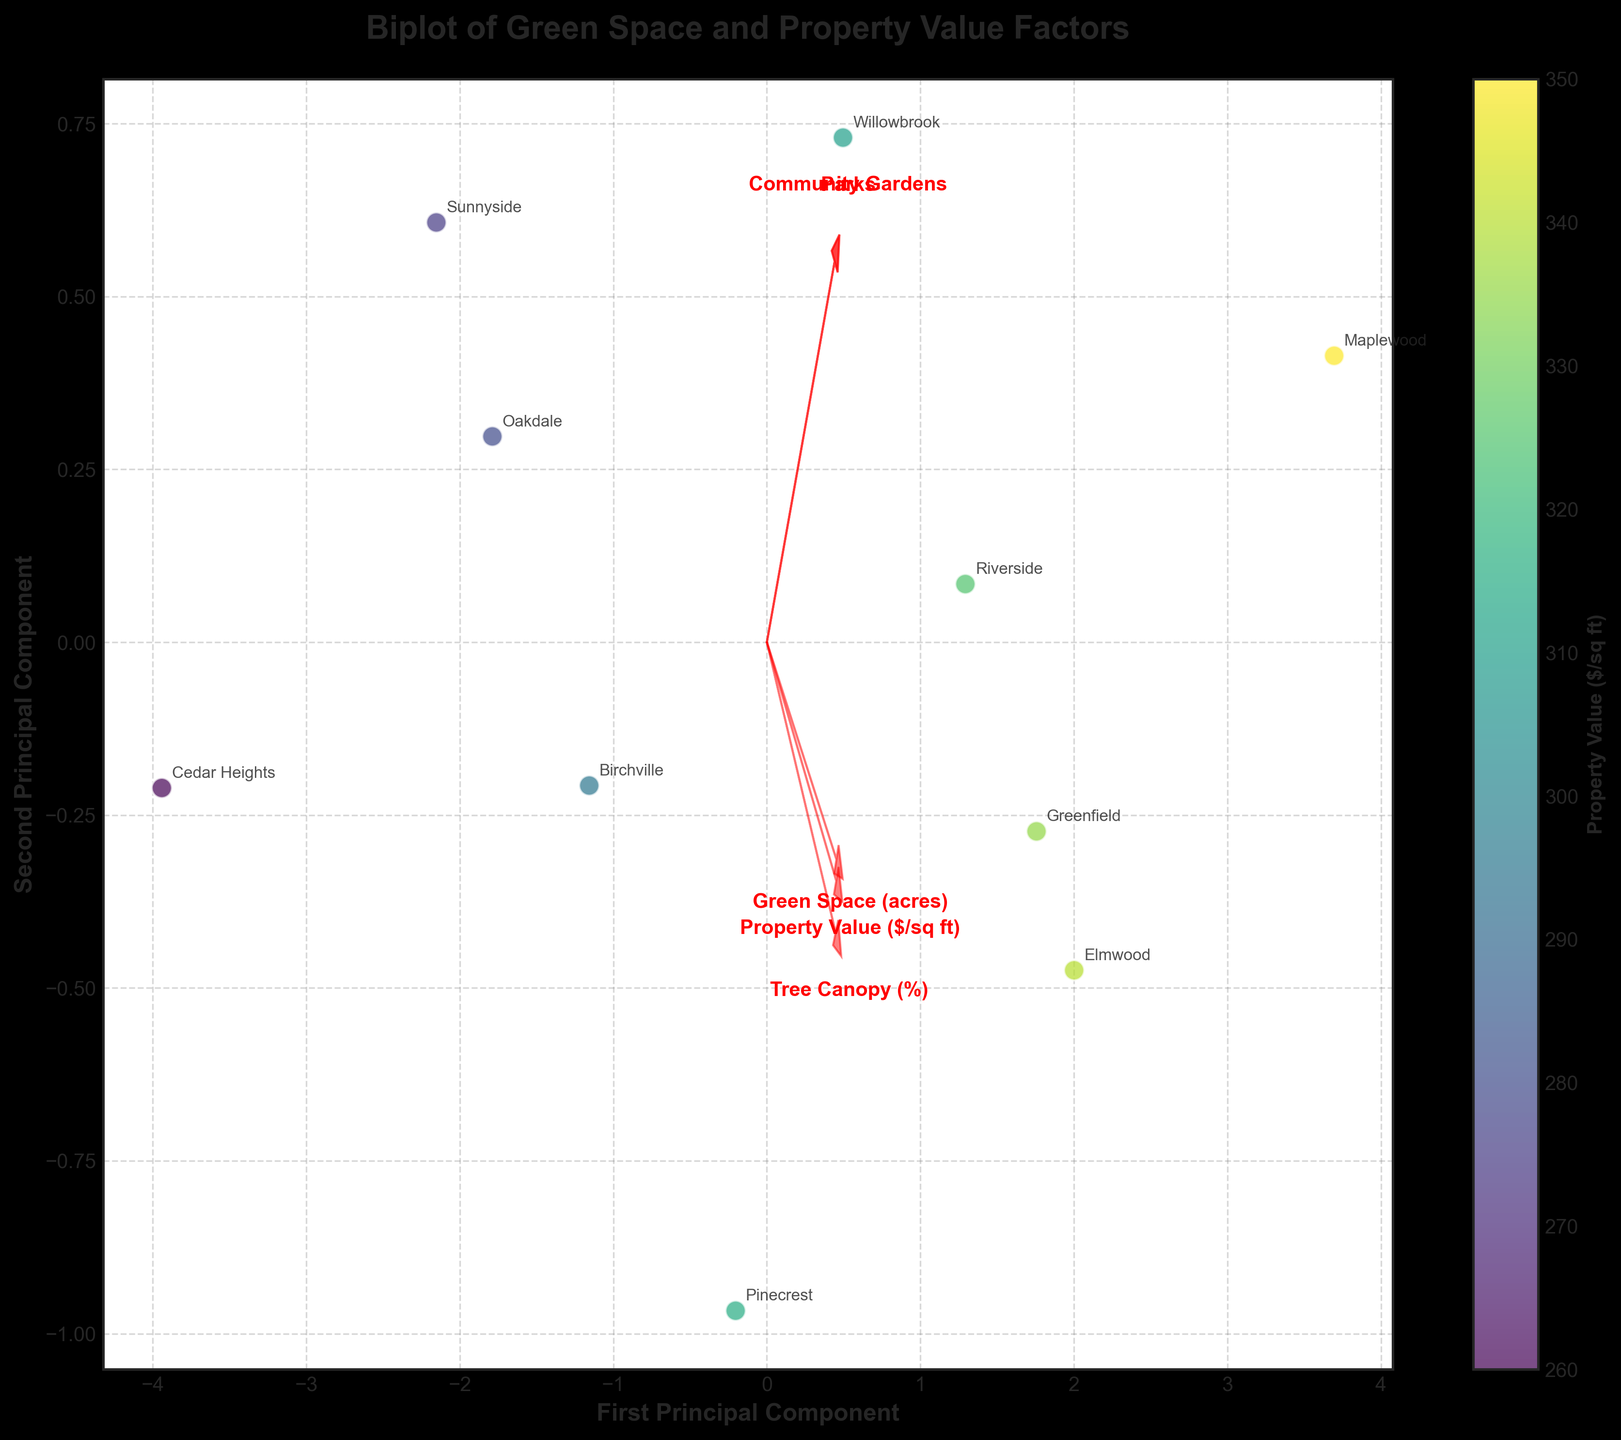What is the title of the plot? The title is usually displayed at the top of the plot and provides a brief description of what the plot represents.
Answer: Biplot of Green Space and Property Value Factors How many neighborhoods are represented in the plot? By counting the number of unique labels (neighborhood names) annotated around the data points, we can determine the number of neighborhoods.
Answer: 10 Which neighborhood shows the highest property value? To determine this, look for the data point that is darkest in color, as the color intensity represents property value.
Answer: Maplewood What are the two principal components labeled on the plot? These are the axes labels, which usually describe the main dimensions along which the data is represented.
Answer: First Principal Component and Second Principal Component Which feature has the longest vector in the biplot? In a biplot, the length of a feature vector indicates its variance with respect to principal components. The longest arrow signifies the feature with the highest variance.
Answer: Property Value ($/sq ft) How does the tree canopy percentage correlate with property value in the neighborhoods? Observe the direction and length of the Tree Canopy (%) vector compared to the Property Value vector. If they point in similar directions, there is a positive correlation; otherwise, there's a negative or no correlation.
Answer: Positive correlation Which neighborhoods have similar property values based on their positions in the biplot? Nearby data points in the biplot suggest similar properties.
Answer: Elmwood and Greenfield Which feature has the smallest influence on the principal components in the plot? The feature with the shortest arrow has the smallest influence on the principal components.
Answer: Parks How is the impact of community gardens on property value represented in the plot? Analyze the direction and length of the "Community Gardens" feature vector. Note how it compares to the "Property Value" vector in terms of angle and proximity.
Answer: Slight positive influence, shorter vector What's the general trend between green space availability and property values across the neighborhoods? Look at the features "Green Space (acres)" and "Property Value ($/sq ft)", observing the direction and relationship of their vectors. If they point in the same direction, the trend is positive; if opposite, negative.
Answer: Positive trend 